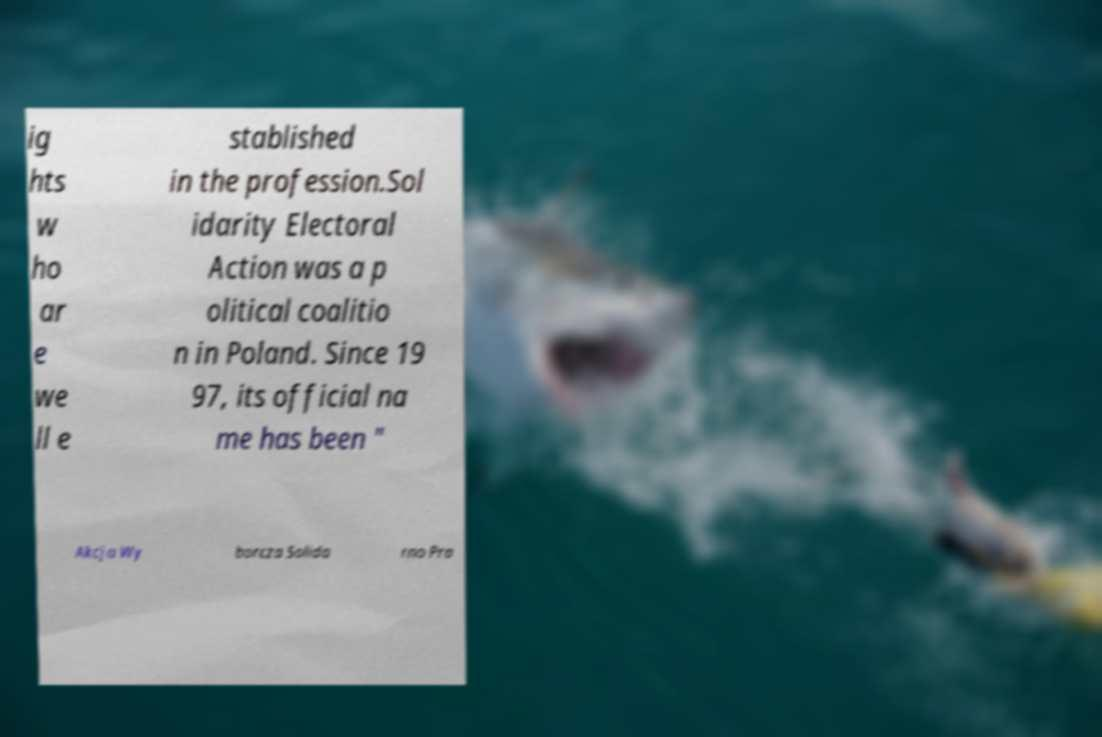I need the written content from this picture converted into text. Can you do that? ig hts w ho ar e we ll e stablished in the profession.Sol idarity Electoral Action was a p olitical coalitio n in Poland. Since 19 97, its official na me has been " Akcja Wy borcza Solida rno Pra 